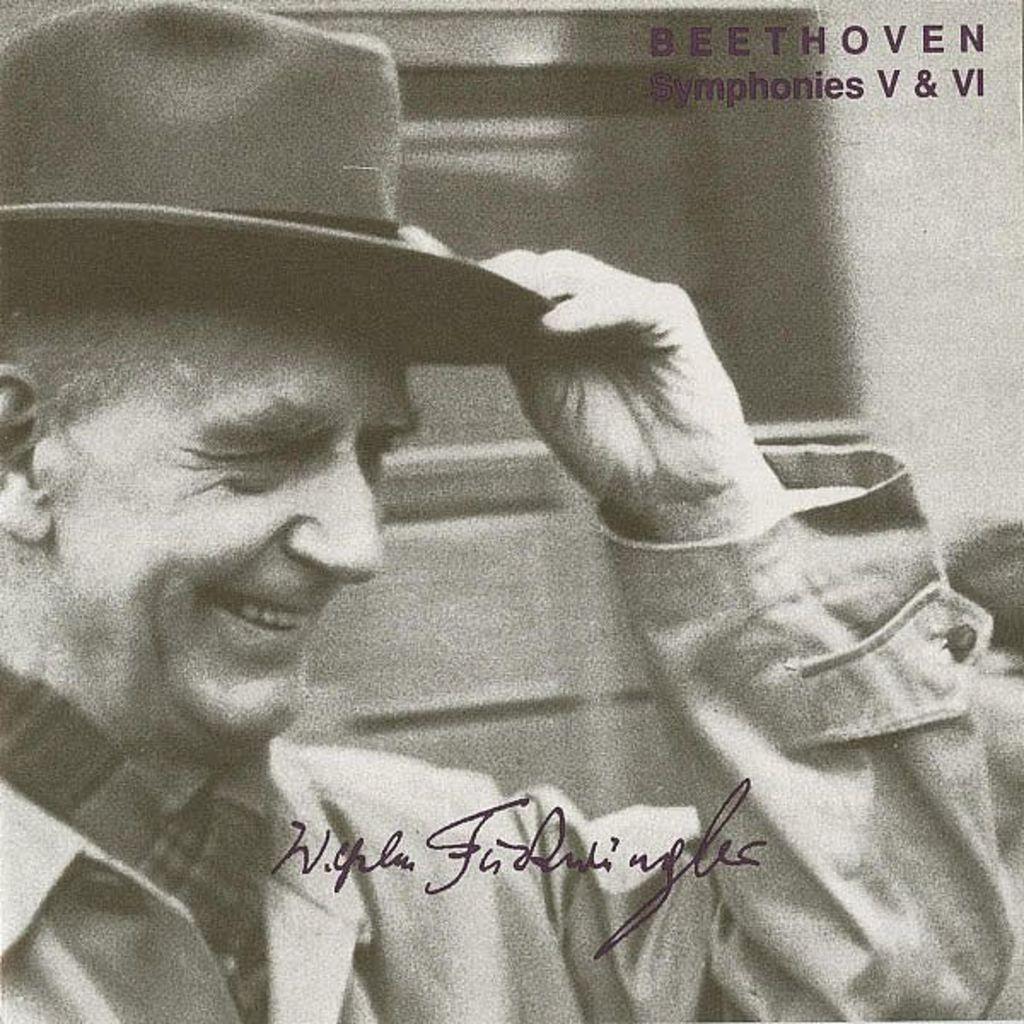Could you give a brief overview of what you see in this image? It looks like a black and white picture. We can see a man with the hat and behind the man there are blurred items and on the image there is a watermark. 